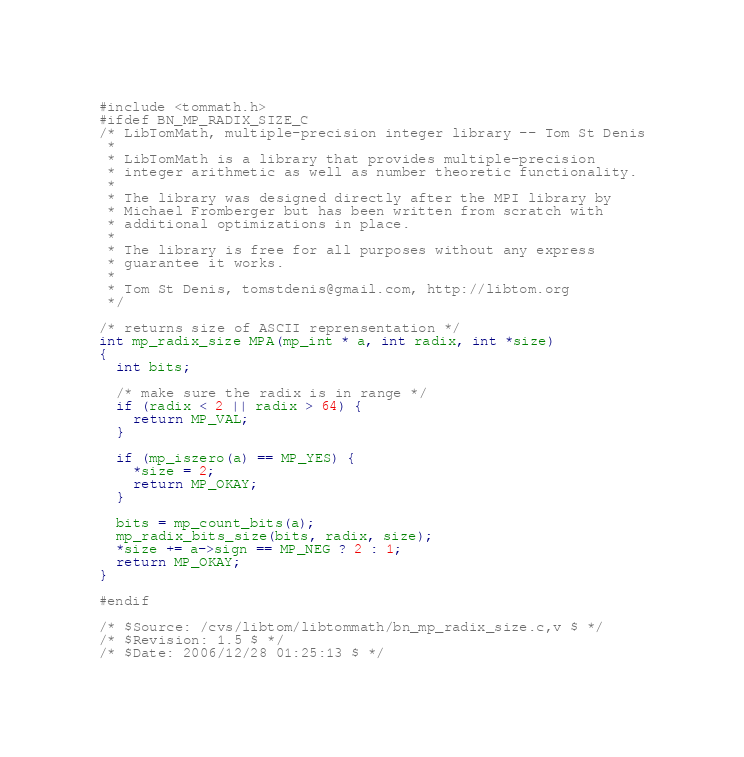<code> <loc_0><loc_0><loc_500><loc_500><_C_>#include <tommath.h>
#ifdef BN_MP_RADIX_SIZE_C
/* LibTomMath, multiple-precision integer library -- Tom St Denis
 *
 * LibTomMath is a library that provides multiple-precision
 * integer arithmetic as well as number theoretic functionality.
 *
 * The library was designed directly after the MPI library by
 * Michael Fromberger but has been written from scratch with
 * additional optimizations in place.
 *
 * The library is free for all purposes without any express
 * guarantee it works.
 *
 * Tom St Denis, tomstdenis@gmail.com, http://libtom.org
 */

/* returns size of ASCII reprensentation */
int mp_radix_size MPA(mp_int * a, int radix, int *size)
{
  int bits;

  /* make sure the radix is in range */
  if (radix < 2 || radix > 64) {
    return MP_VAL;
  }

  if (mp_iszero(a) == MP_YES) {
    *size = 2;
    return MP_OKAY;
  }

  bits = mp_count_bits(a);
  mp_radix_bits_size(bits, radix, size);
  *size += a->sign == MP_NEG ? 2 : 1;
  return MP_OKAY;
}

#endif

/* $Source: /cvs/libtom/libtommath/bn_mp_radix_size.c,v $ */
/* $Revision: 1.5 $ */
/* $Date: 2006/12/28 01:25:13 $ */
</code> 